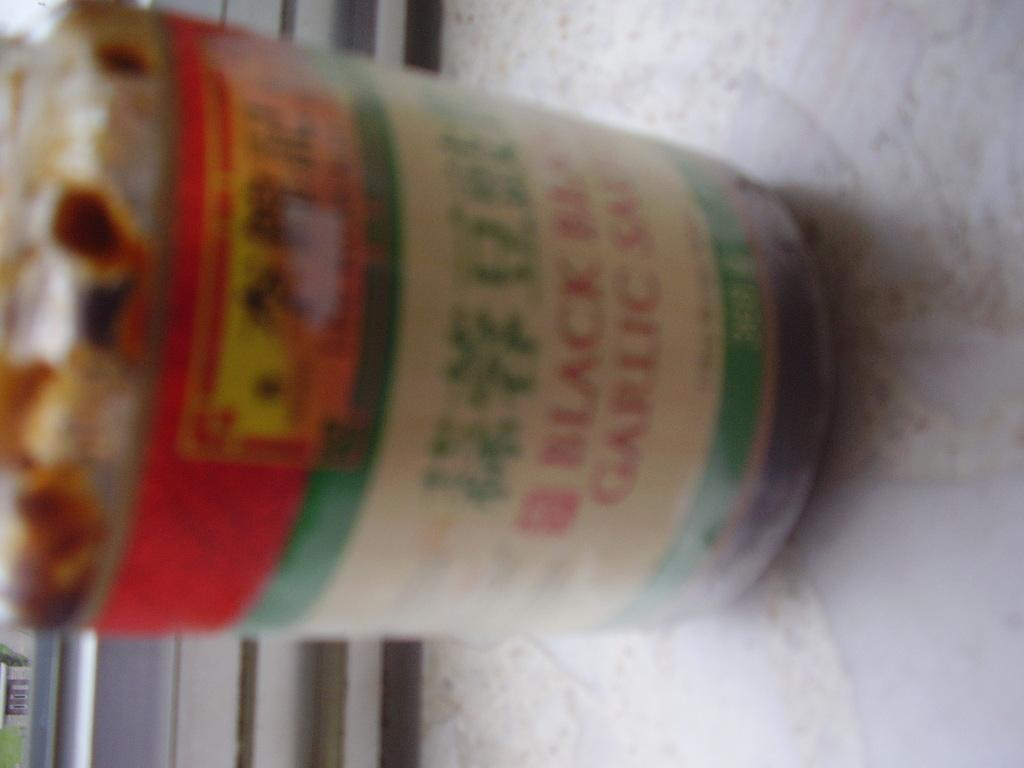What is the main subject of the picture? The main subject of the picture is a partial part of a jar. Can you describe the jar in more detail? Unfortunately, the provided facts do not give more details about the jar. What role does the father play in the image? There is no reference to a father or any people in the image, so it's not possible to determine the father's role. 